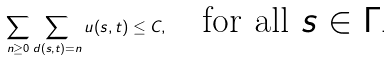<formula> <loc_0><loc_0><loc_500><loc_500>\sum _ { n \geq 0 } \sum _ { d ( s , t ) = n } u ( s , t ) \leq C , \quad \text {for all $s\in\Gamma$} .</formula> 